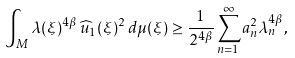Convert formula to latex. <formula><loc_0><loc_0><loc_500><loc_500>\int _ { M } \lambda ( \xi ) ^ { 4 \beta } \, \widehat { u } _ { 1 } ( \xi ) ^ { 2 } \, d \mu ( \xi ) \geq \frac { 1 } { 2 ^ { 4 \beta } } \sum _ { n = 1 } ^ { \infty } a _ { n } ^ { 2 } \lambda _ { n } ^ { 4 \beta } ,</formula> 